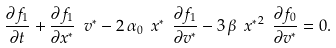Convert formula to latex. <formula><loc_0><loc_0><loc_500><loc_500>\frac { \partial f _ { 1 } } { \partial t } + \frac { \partial f _ { 1 } } { \partial x ^ { * } } \ v ^ { * } - 2 \, \alpha _ { 0 } \ x ^ { * } \ \frac { \partial f _ { 1 } } { \partial v ^ { * } } - 3 \, \beta \ { x ^ { * } } ^ { 2 } \ \frac { \partial f _ { 0 } } { \partial v ^ { * } } = 0 .</formula> 